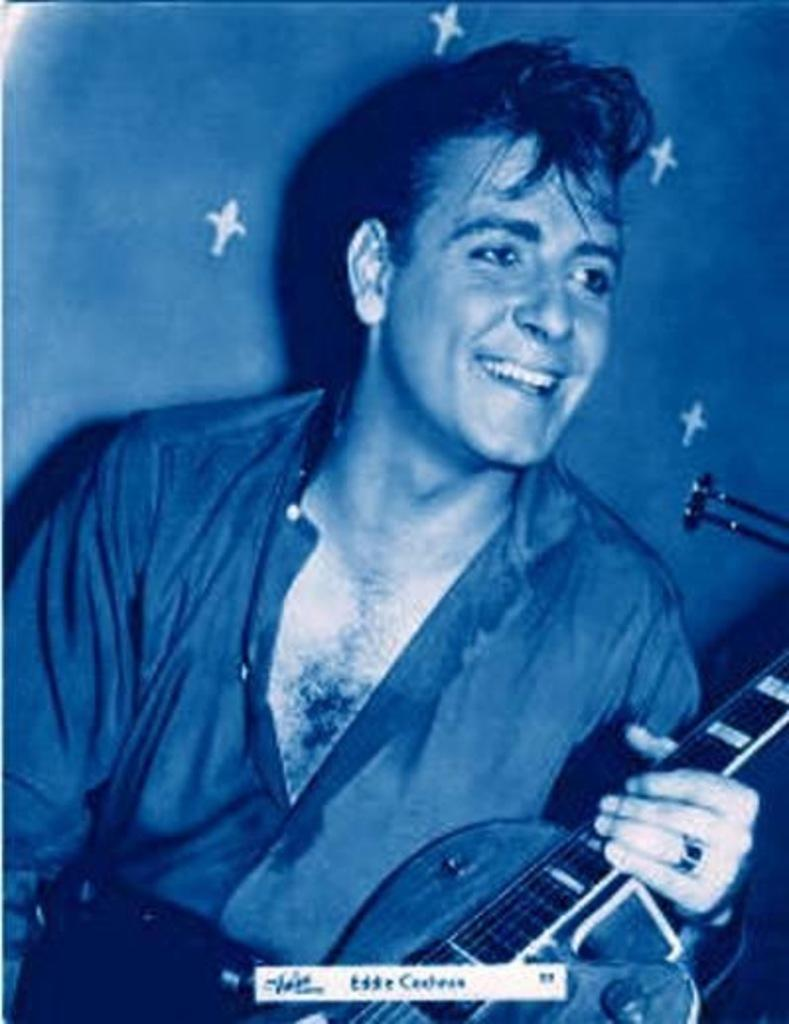What is the man in the image holding? The man is holding a guitar. What is the man's facial expression in the image? The man is smiling. What type of sign is the man holding in the image? There is no sign present in the image; the man is holding a guitar. Can you see any spots on the man's clothing in the image? The provided facts do not mention any spots on the man's clothing, so it cannot be determined from the image. 